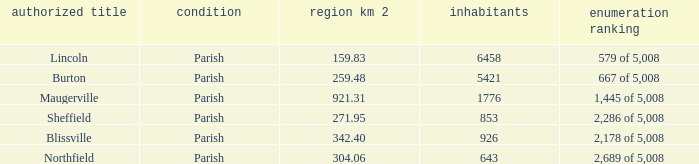What are the official name(s) of places with an area of 304.06 km2? Northfield. 